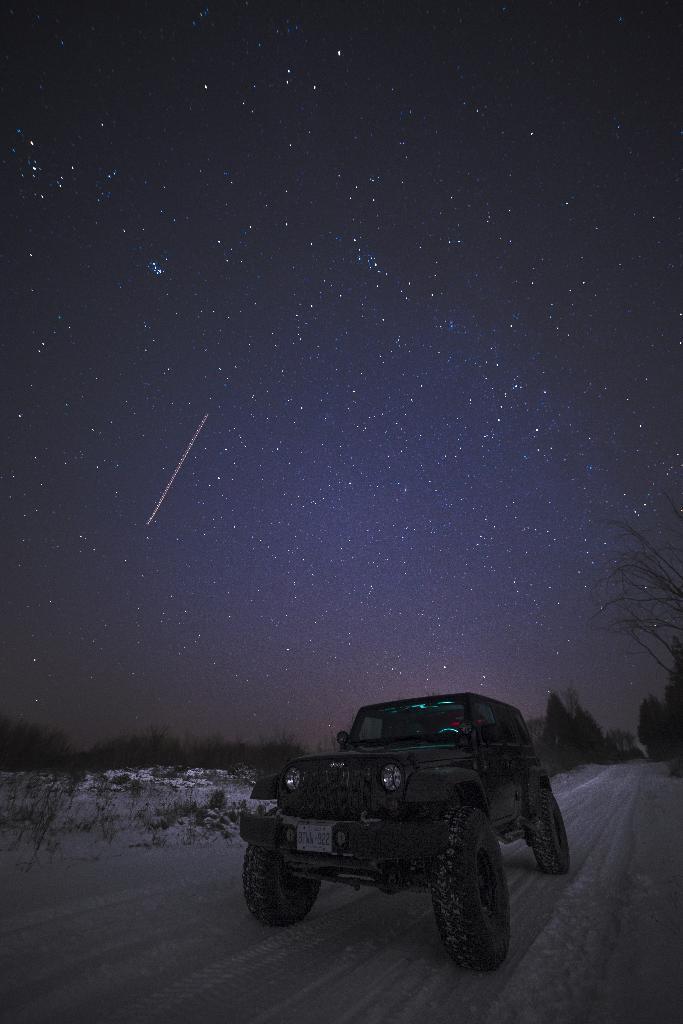Please provide a concise description of this image. In this image I can see the vehicle on the snow. In the back I can see many trees, stars and the sky. 